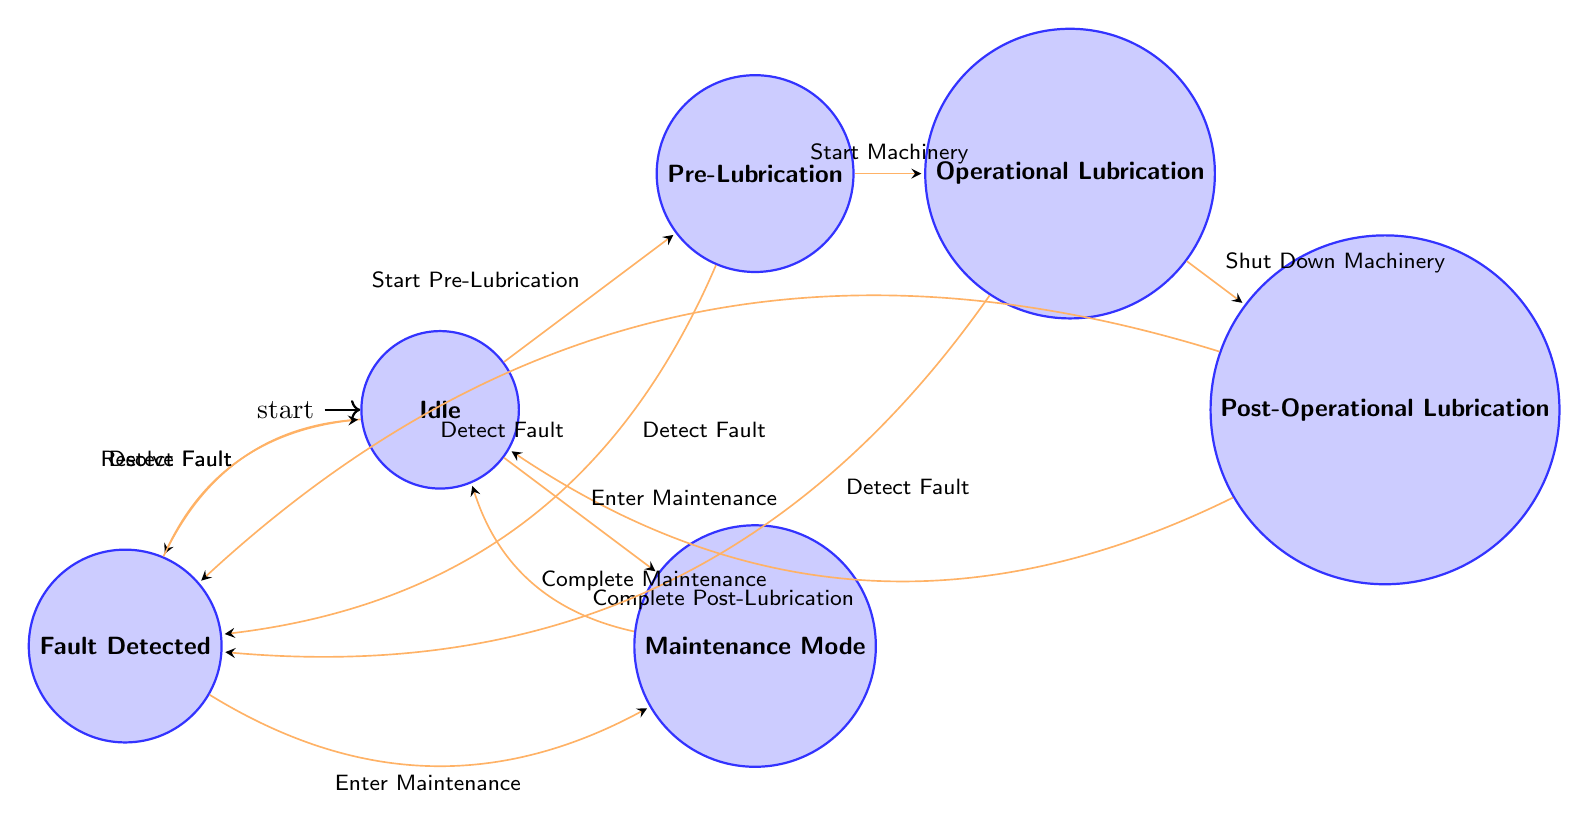What is the initial state of the lubrication system? The diagram indicates that the initial state is labeled as "Idle." Therefore, when the system is first activated or before any processes begin, it remains in this state.
Answer: Idle How many states are present in the diagram? Counting through the states displayed in the diagram, we can identify a total of six states: Idle, Pre-Lubrication, Operational Lubrication, Post-Operational Lubrication, Fault Detected, and Maintenance Mode.
Answer: 6 What transition occurs after "Shut Down Machinery"? According to the diagram, the transition that follows "Shut Down Machinery" leads to the state known as "Post-Operational Lubrication." This move signifies that the system continues lubrication even after the machinery is stopped.
Answer: Post-Operational Lubrication Which state can transition into "Fault Detected"? The diagram shows that multiple states can lead to "Fault Detected," specifically from Idle, Pre-Lubrication, Operational Lubrication, and Post-Operational Lubrication. Any of these states can experience a fault detection event.
Answer: Idle, Pre-Lubrication, Operational Lubrication, Post-Operational Lubrication To which state does the "Complete Maintenance" transition lead? The transition labeled "Complete Maintenance" moves the system back to the "Idle" state, indicating that after maintenance is completed, the lubrication system returns to its inactive state.
Answer: Idle What occurs after "Fault Detected" when resolved? Once the fault is detected and subsequently resolved, the transition indicates that the system returns to the "Idle" state, effectively resetting after the issue has been addressed.
Answer: Idle How does one enter "Maintenance Mode"? "Maintenance Mode" can be entered from two possible states: "Idle" or "Fault Detected." Therefore, if either the system is idle or an issue has been identified, the lubrication system can switch to maintenance.
Answer: Idle, Fault Detected 